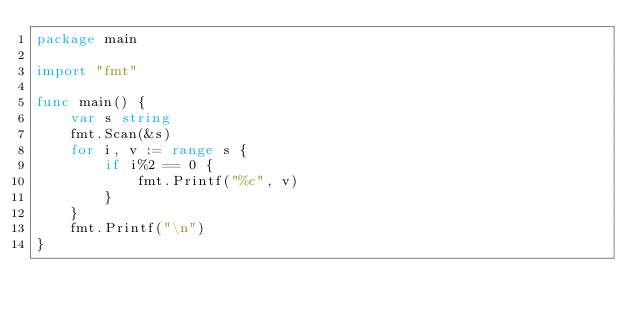<code> <loc_0><loc_0><loc_500><loc_500><_Go_>package main

import "fmt"

func main() {
	var s string
	fmt.Scan(&s)
	for i, v := range s {
		if i%2 == 0 {
			fmt.Printf("%c", v)
		}
	}
	fmt.Printf("\n")
}
</code> 